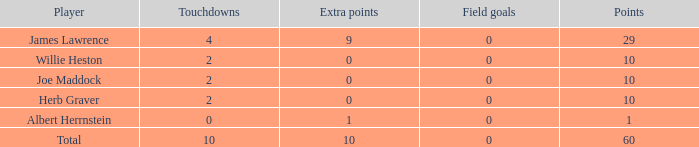What is the highest number of extra points for players with less than 2 touchdowns and less than 1 point? None. 